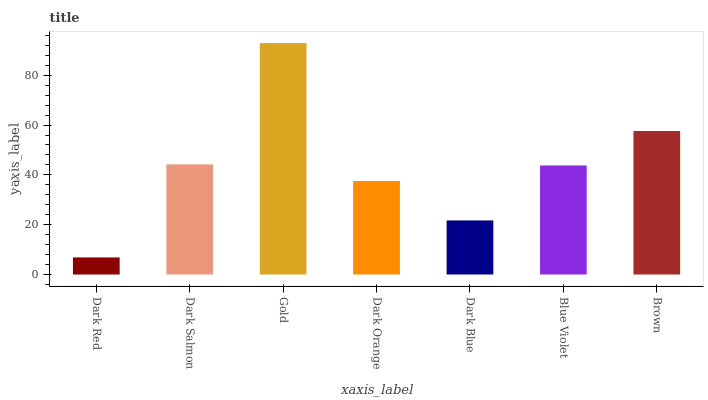Is Dark Red the minimum?
Answer yes or no. Yes. Is Gold the maximum?
Answer yes or no. Yes. Is Dark Salmon the minimum?
Answer yes or no. No. Is Dark Salmon the maximum?
Answer yes or no. No. Is Dark Salmon greater than Dark Red?
Answer yes or no. Yes. Is Dark Red less than Dark Salmon?
Answer yes or no. Yes. Is Dark Red greater than Dark Salmon?
Answer yes or no. No. Is Dark Salmon less than Dark Red?
Answer yes or no. No. Is Blue Violet the high median?
Answer yes or no. Yes. Is Blue Violet the low median?
Answer yes or no. Yes. Is Dark Salmon the high median?
Answer yes or no. No. Is Dark Orange the low median?
Answer yes or no. No. 